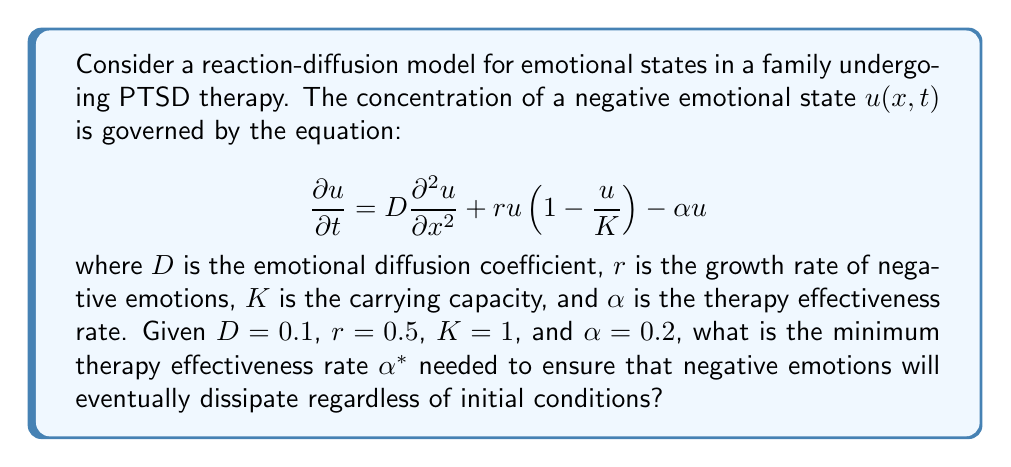Can you solve this math problem? To solve this problem, we need to analyze the stability of the steady-state solutions of the reaction-diffusion equation. The steady-state solutions are found by setting $\frac{\partial u}{\partial t} = 0$:

$$0 = D\frac{\partial^2 u}{\partial x^2} + ru(1-\frac{u}{K}) - \alpha u$$

For spatially homogeneous solutions, $\frac{\partial^2 u}{\partial x^2} = 0$, so we have:

$$ru(1-\frac{u}{K}) - \alpha u = 0$$

This equation has two solutions: $u=0$ and $u=K(1-\frac{\alpha}{r})$. 

For the negative emotions to dissipate, we need the non-zero solution to be negative or non-existent. This occurs when:

$$K(1-\frac{\alpha}{r}) \leq 0$$

Solving this inequality:

$$1-\frac{\alpha}{r} \leq 0$$
$$\frac{\alpha}{r} \geq 1$$
$$\alpha \geq r$$

Therefore, the minimum therapy effectiveness rate $\alpha^*$ needed to ensure that negative emotions will eventually dissipate is equal to the growth rate of negative emotions, $r$.

Given $r=0.5$, we have $\alpha^* = 0.5$.

To verify that this is indeed the minimum rate, we can check that when $\alpha = 0.5$:

1. The non-zero steady-state solution becomes $u = K(1-\frac{0.5}{0.5}) = 0$
2. The zero solution $u=0$ is stable

This confirms that $\alpha^* = 0.5$ is the minimum therapy effectiveness rate needed.
Answer: $\alpha^* = 0.5$ 